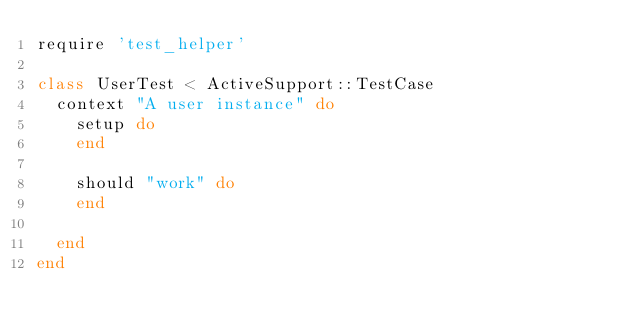Convert code to text. <code><loc_0><loc_0><loc_500><loc_500><_Ruby_>require 'test_helper'

class UserTest < ActiveSupport::TestCase
  context "A user instance" do
    setup do
    end

    should "work" do
    end

  end
end

</code> 